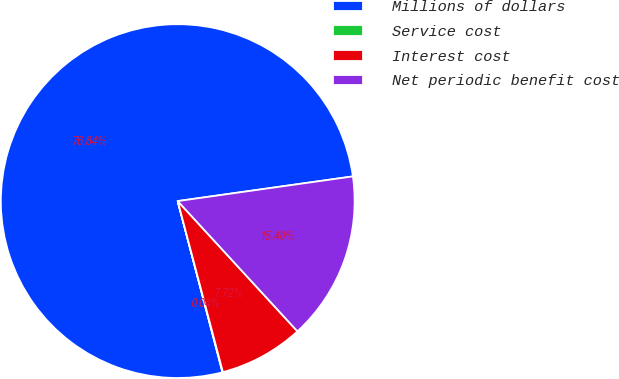Convert chart. <chart><loc_0><loc_0><loc_500><loc_500><pie_chart><fcel>Millions of dollars<fcel>Service cost<fcel>Interest cost<fcel>Net periodic benefit cost<nl><fcel>76.84%<fcel>0.04%<fcel>7.72%<fcel>15.4%<nl></chart> 